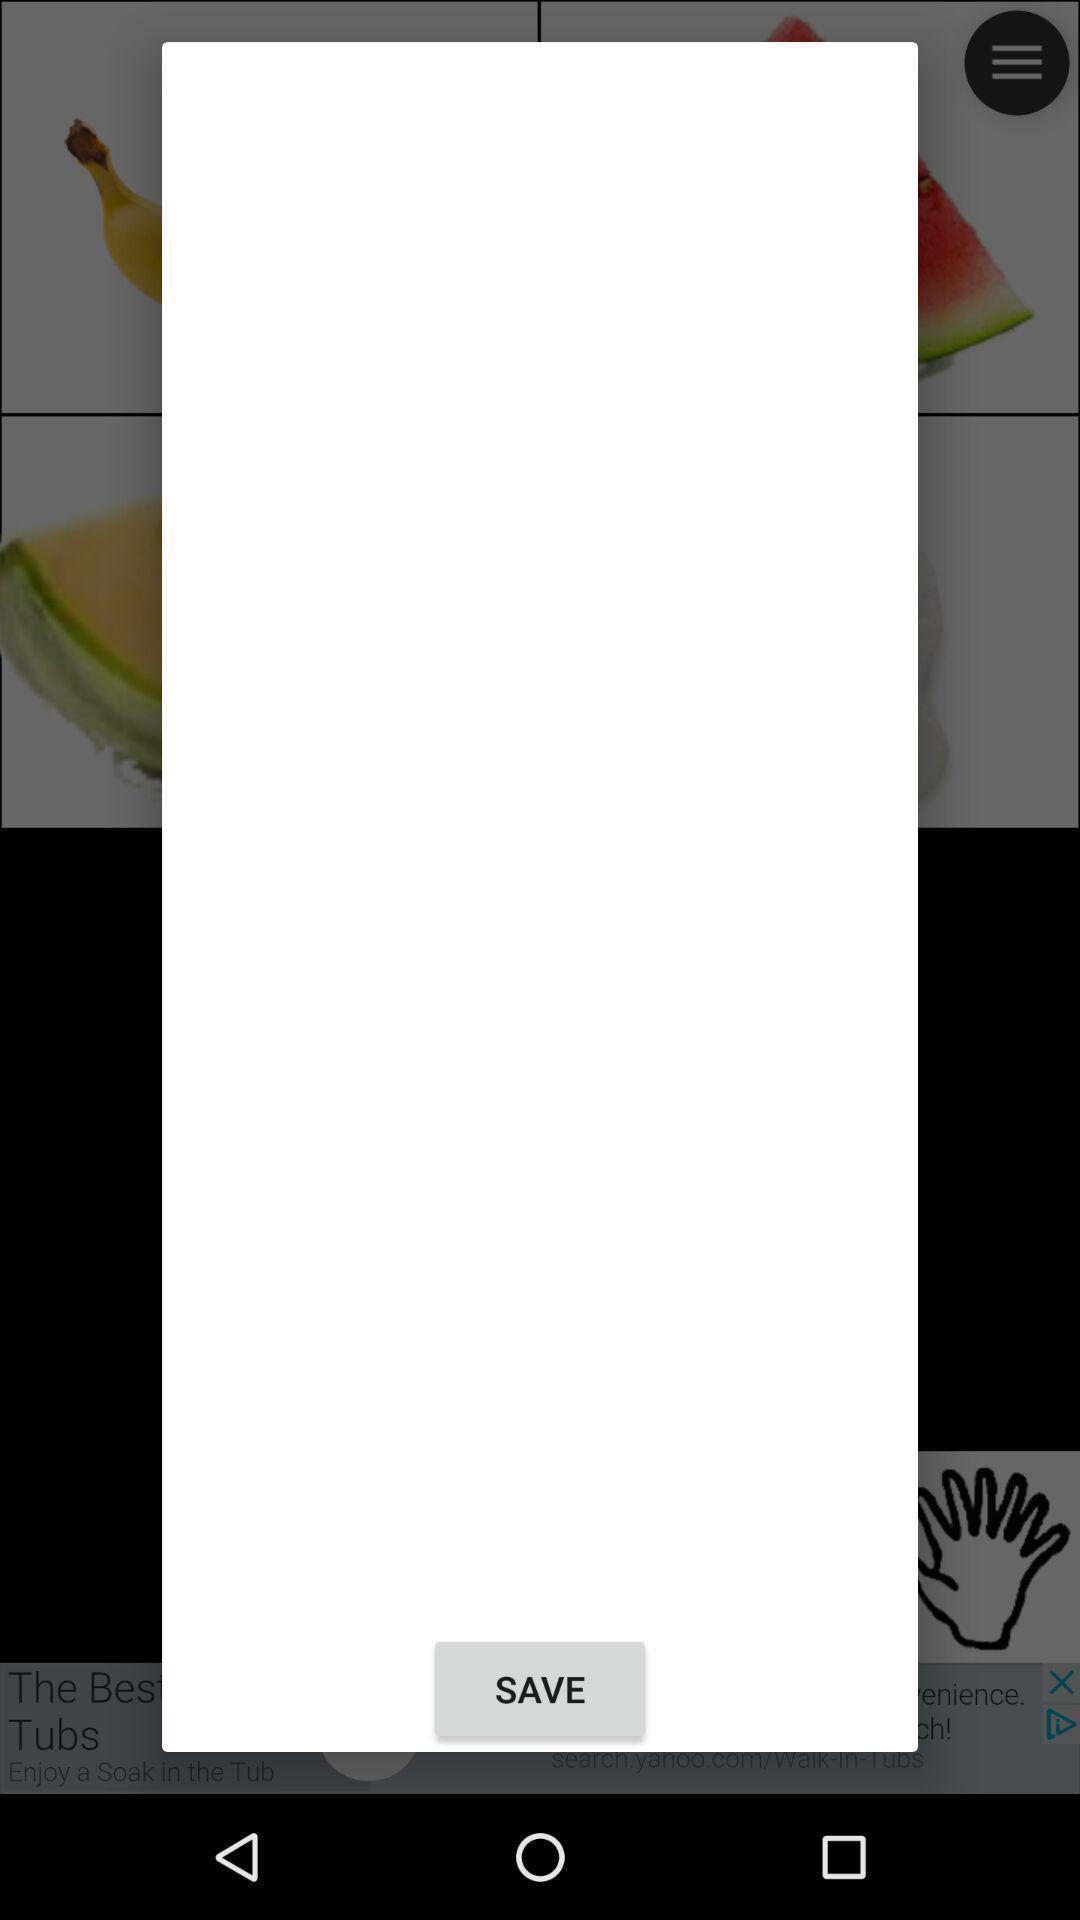Explain what's happening in this screen capture. Pop-up window showing blank page with save option. 